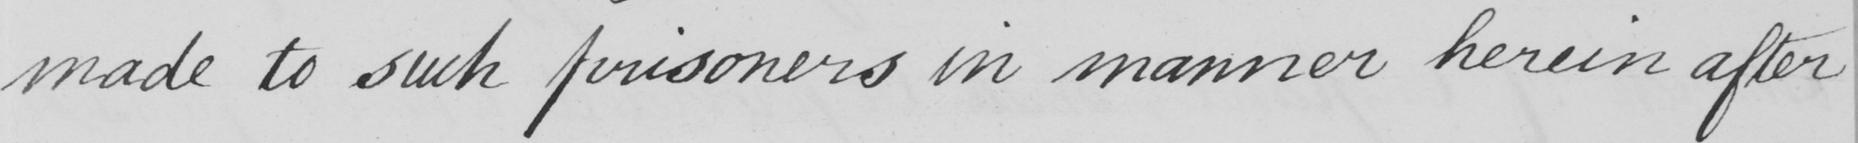What is written in this line of handwriting? made to such prisoners in manner herein after 